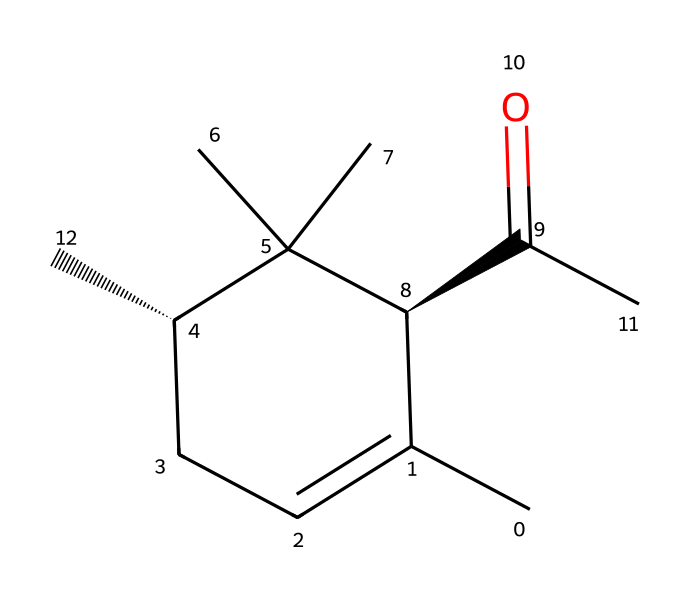what is the molecular formula of this compound? To determine the molecular formula, we analyze the SMILES representation, where the carbon (C), hydrogen (H), and oxygen (O) atoms can be counted. The structure indicates several carbon and hydrogen atoms, leading to the formula C13H18O.
Answer: C13H18O how many rings are present in this structure? By examining the SMILES notation, we see that there is a cyclohexane ring, represented by the "C1" that marks the beginning and end of the ring. There is only one such ring in this structure.
Answer: 1 which functional group is prominently featured in this chemical? In the provided structure, the presence of oxygen connected to carbon indicates the presence of an ether functional group. This is characterized by the C-O-C linkage present in ether compounds.
Answer: ether how many chirality centers are in this molecule? The presence of chirality centers is identified by the "@" symbols in the SMILES notation, which indicate stereocenters. By counting these symbols, we determine there are two chirality centers in this compound.
Answer: 2 is this compound typically soluble in water? Ethers are generally characterized by low solubility in water due to their nonpolar carbon chains compared to the polar ether oxygen. Therefore, this compound is expected to have low water solubility.
Answer: low what type of reaction could this molecule participate in? Considering this molecule is an ether, it could participate in nucleophilic substitution reactions typically seen with ethers when reacted with strong acids or nucleophiles, due to the presence of the ether functional group.
Answer: nucleophilic substitution does this molecule contain any double bonds? The SMILES representation does not show a double bond indicator between any carbon atoms, indicating that all connections in this structure are single bonds.
Answer: no 